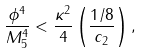Convert formula to latex. <formula><loc_0><loc_0><loc_500><loc_500>\frac { \phi ^ { 4 } } { M _ { 5 } ^ { 4 } } < \frac { \kappa ^ { 2 } } { 4 } \left ( \frac { 1 / 8 } { c _ { 2 } } \right ) ,</formula> 